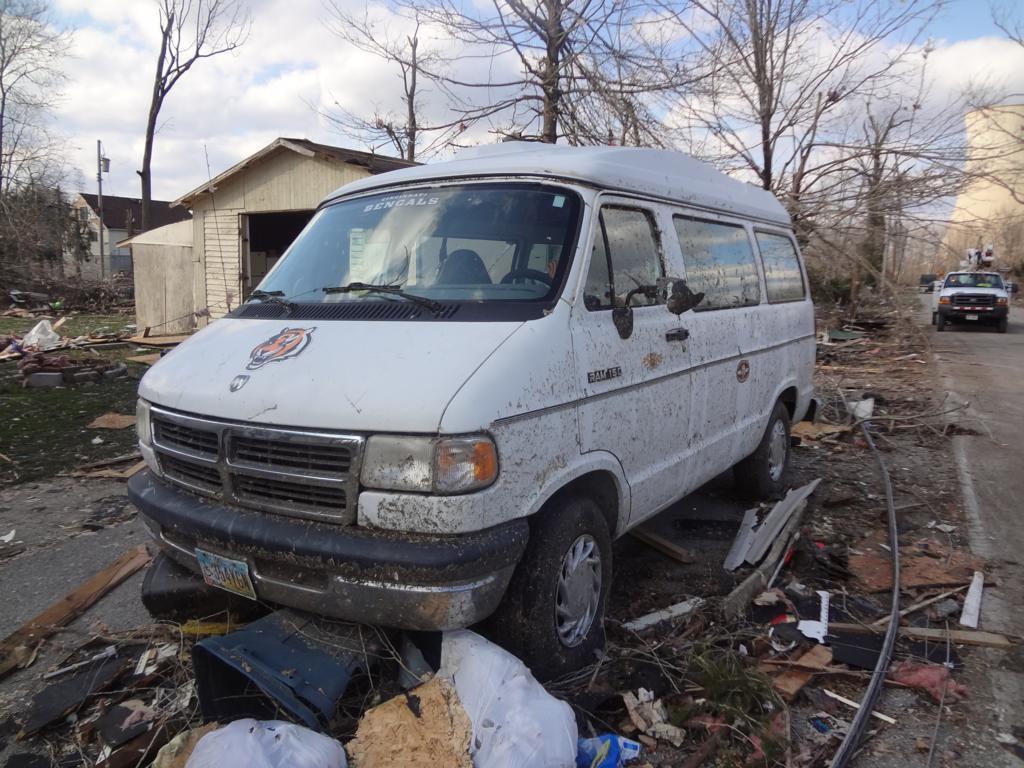Do they have a bengals sticker on their windshield?
Make the answer very short. Yes. What kind of van is it?
Keep it short and to the point. Ram 150. 